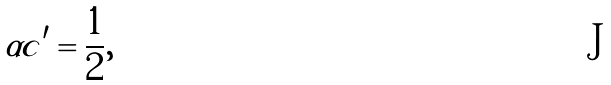Convert formula to latex. <formula><loc_0><loc_0><loc_500><loc_500>\alpha c ^ { \prime } = \frac { 1 } { 2 } ,</formula> 